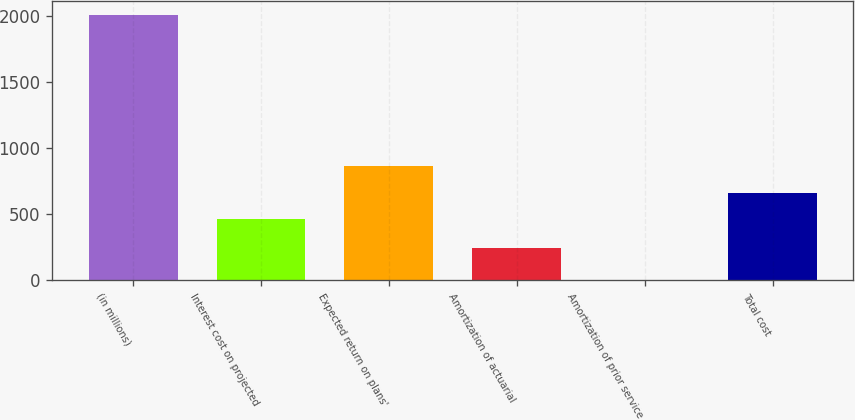Convert chart to OTSL. <chart><loc_0><loc_0><loc_500><loc_500><bar_chart><fcel>(in millions)<fcel>Interest cost on projected<fcel>Expected return on plans'<fcel>Amortization of actuarial<fcel>Amortization of prior service<fcel>Total cost<nl><fcel>2012<fcel>460<fcel>862<fcel>244<fcel>2<fcel>661<nl></chart> 